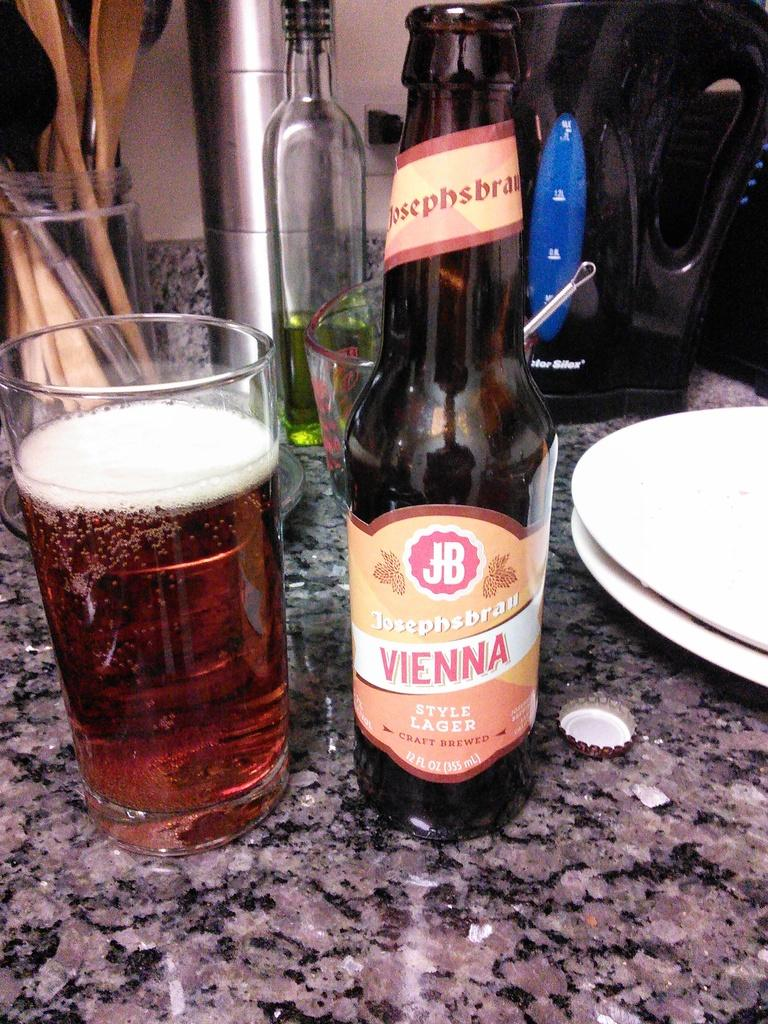<image>
Relay a brief, clear account of the picture shown. A beer bottle set on the table with the word vienna on it. 